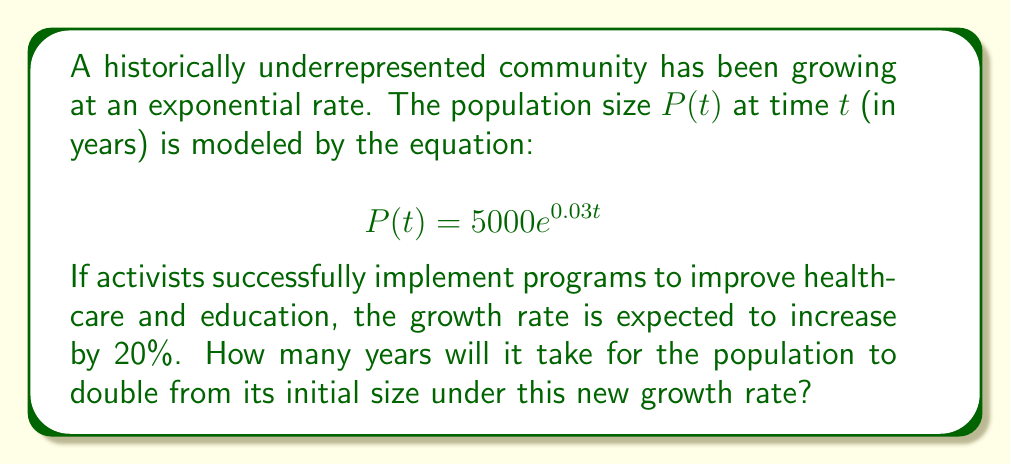Help me with this question. To solve this problem, we'll follow these steps:

1) First, we need to determine the new growth rate:
   Original rate: $r = 0.03$
   Increase: $20\% = 0.2$
   New rate: $r_{new} = 0.03 \times (1 + 0.2) = 0.03 \times 1.2 = 0.036$

2) The new population model will be:
   $$P(t) = 5000e^{0.036t}$$

3) To find when the population doubles, we set up the equation:
   $$5000e^{0.036t} = 2 \times 5000$$

4) Simplify:
   $$e^{0.036t} = 2$$

5) Take the natural log of both sides:
   $$\ln(e^{0.036t}) = \ln(2)$$
   $$0.036t = \ln(2)$$

6) Solve for $t$:
   $$t = \frac{\ln(2)}{0.036}$$

7) Calculate:
   $$t = \frac{0.693147...}{0.036} \approx 19.25$$

8) Round to the nearest year:
   $t \approx 19$ years
Answer: It will take approximately 19 years for the population to double under the new growth rate. 